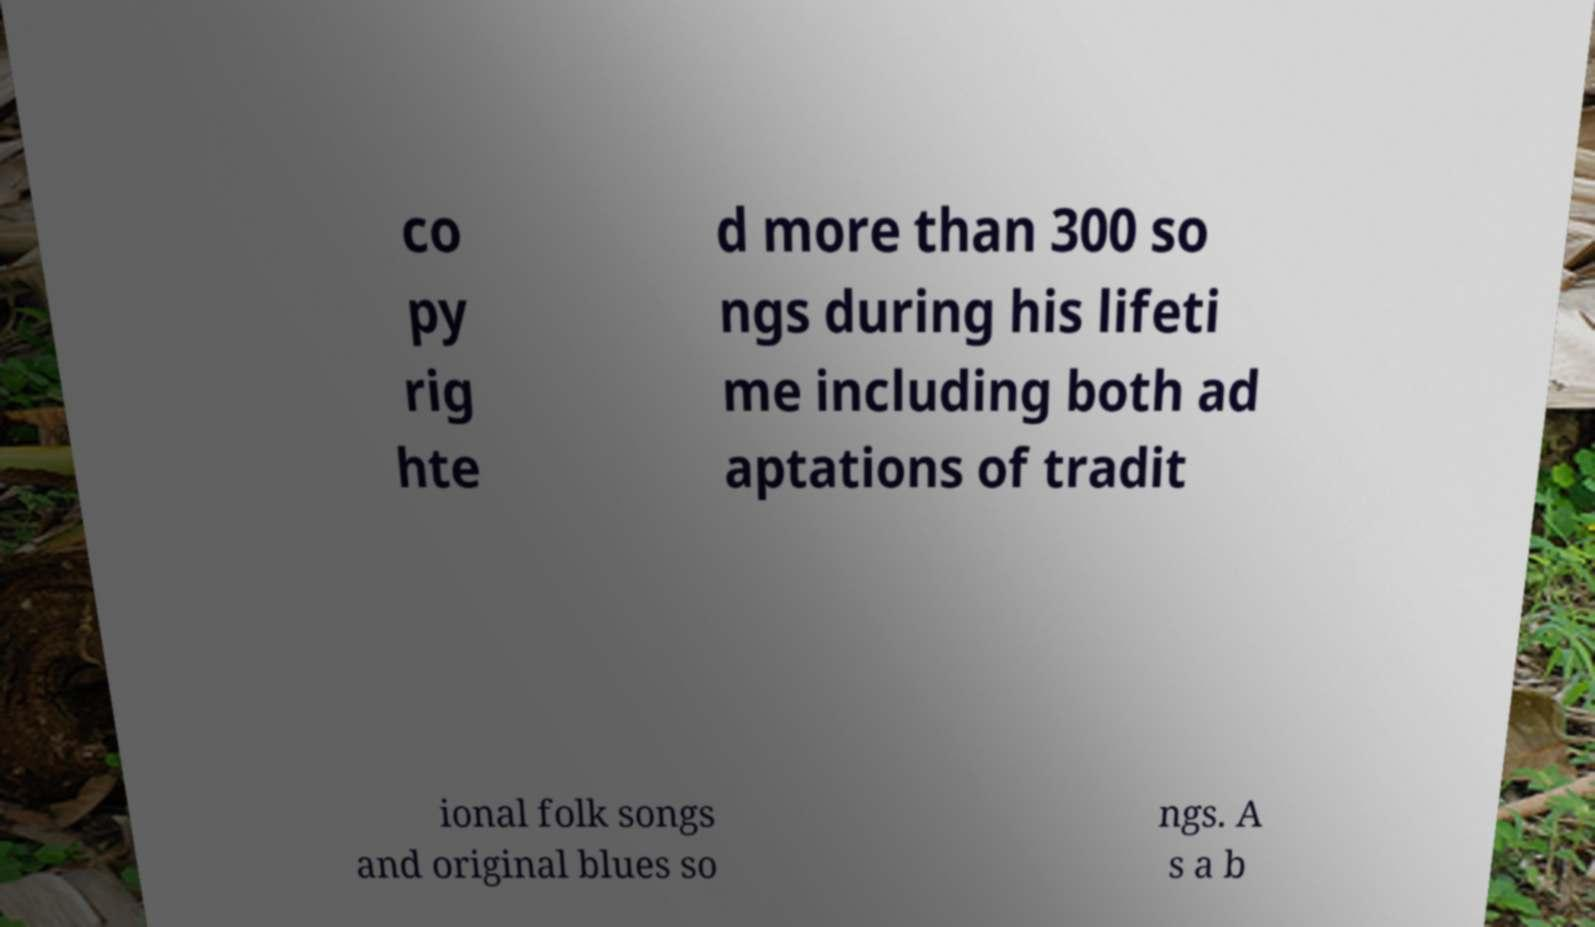Please identify and transcribe the text found in this image. co py rig hte d more than 300 so ngs during his lifeti me including both ad aptations of tradit ional folk songs and original blues so ngs. A s a b 